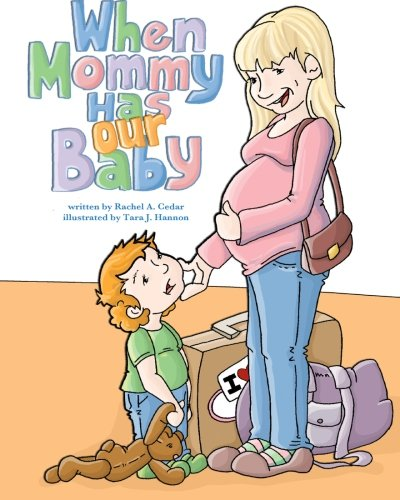What is the genre of this book? The genre of this book is classified under 'Parenting & Relationships,' focusing on family dynamics and child preparation for new siblings. 